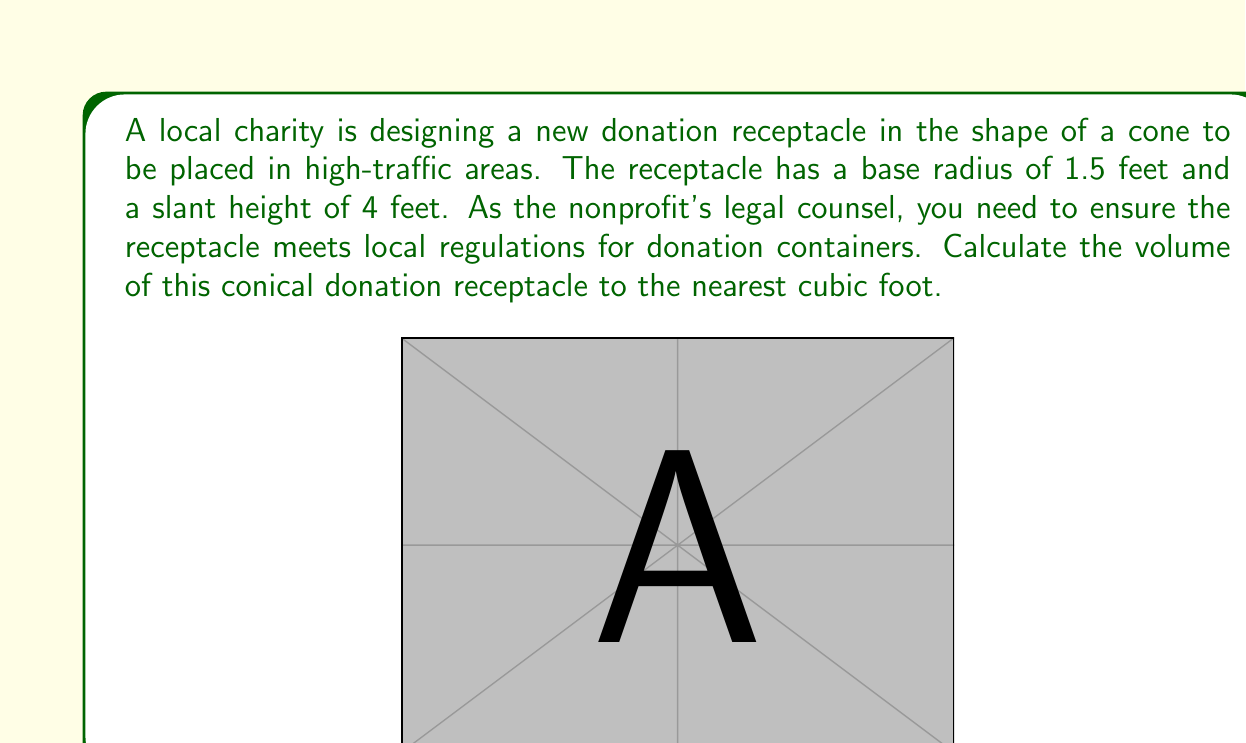Show me your answer to this math problem. To calculate the volume of a cone, we need to use the formula:

$$V = \frac{1}{3}\pi r^2 h$$

Where:
$V$ = volume
$r$ = radius of the base
$h$ = height of the cone (not the slant height)

We are given the slant height $(s)$ and the radius $(r)$, but we need to find the height $(h)$ of the cone.

We can use the Pythagorean theorem to find the height:

$$r^2 + h^2 = s^2$$

Substituting the known values:

$$1.5^2 + h^2 = 4^2$$
$$2.25 + h^2 = 16$$
$$h^2 = 13.75$$
$$h = \sqrt{13.75} \approx 3.708 \text{ feet}$$

Now we can calculate the volume:

$$V = \frac{1}{3}\pi r^2 h$$
$$V = \frac{1}{3}\pi (1.5)^2 (3.708)$$
$$V = \frac{1}{3}\pi (2.25) (3.708)$$
$$V = 8.725\pi \approx 27.41 \text{ cubic feet}$$

Rounding to the nearest cubic foot, we get 27 cubic feet.
Answer: The volume of the conical donation receptacle is approximately 27 cubic feet. 